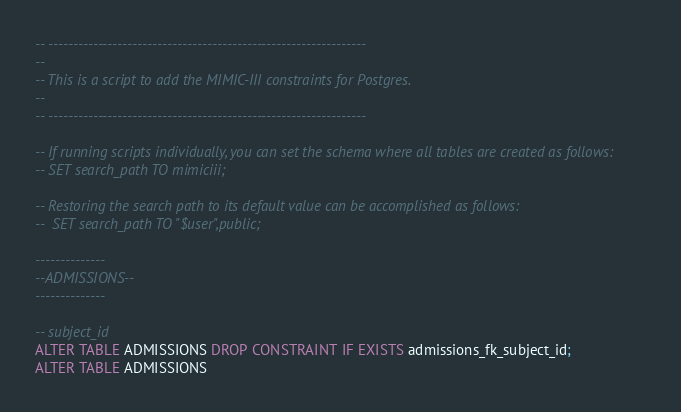<code> <loc_0><loc_0><loc_500><loc_500><_SQL_>-- ----------------------------------------------------------------
--
-- This is a script to add the MIMIC-III constraints for Postgres.
--
-- ----------------------------------------------------------------

-- If running scripts individually, you can set the schema where all tables are created as follows:
-- SET search_path TO mimiciii;

-- Restoring the search path to its default value can be accomplished as follows:
--  SET search_path TO "$user",public;

--------------
--ADMISSIONS--
--------------

-- subject_id
ALTER TABLE ADMISSIONS DROP CONSTRAINT IF EXISTS admissions_fk_subject_id;
ALTER TABLE ADMISSIONS</code> 